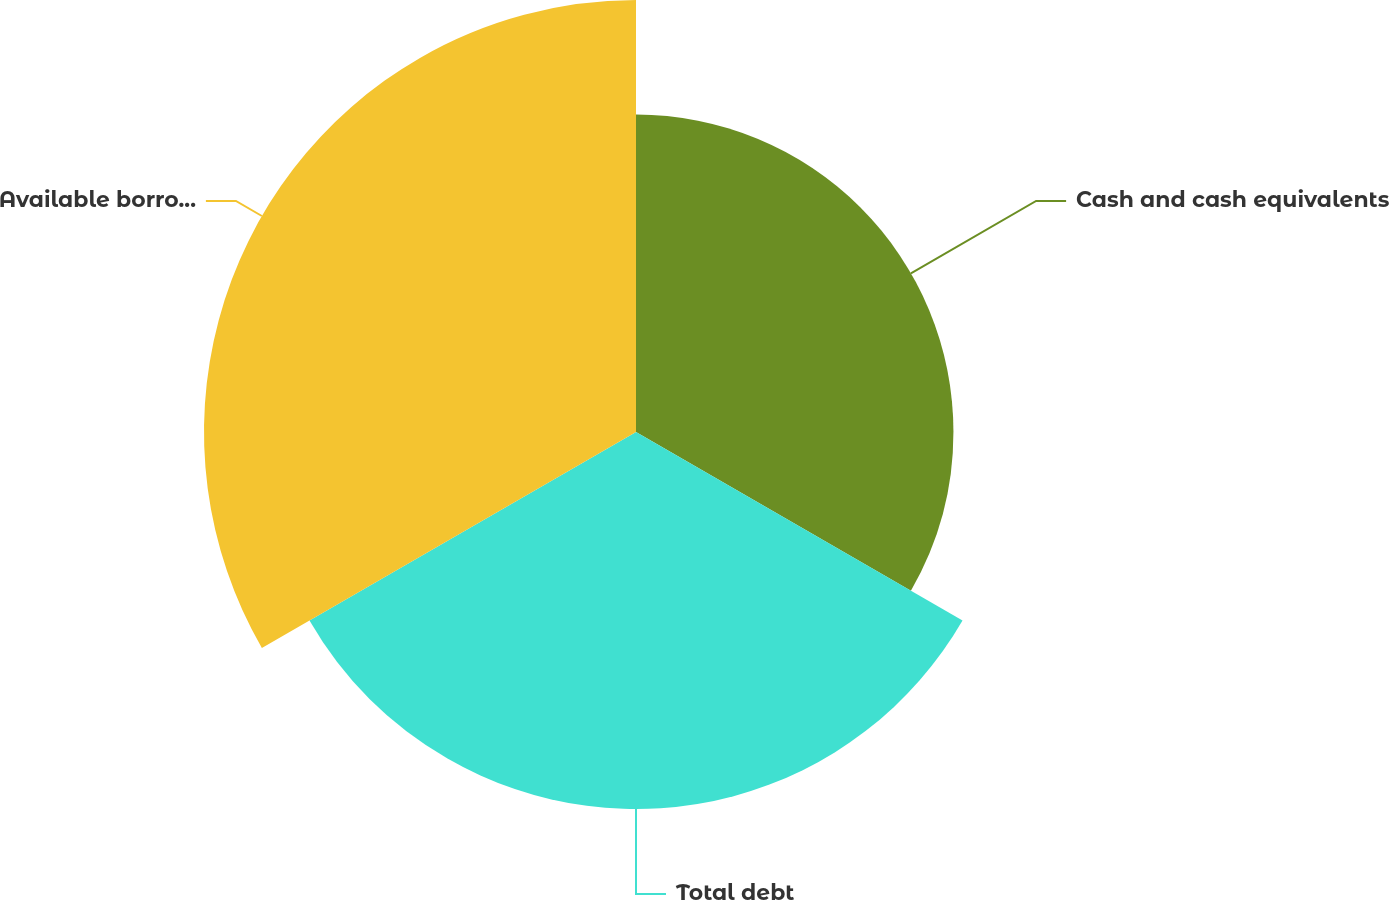Convert chart to OTSL. <chart><loc_0><loc_0><loc_500><loc_500><pie_chart><fcel>Cash and cash equivalents<fcel>Total debt<fcel>Available borrowing resources<nl><fcel>28.18%<fcel>33.47%<fcel>38.35%<nl></chart> 